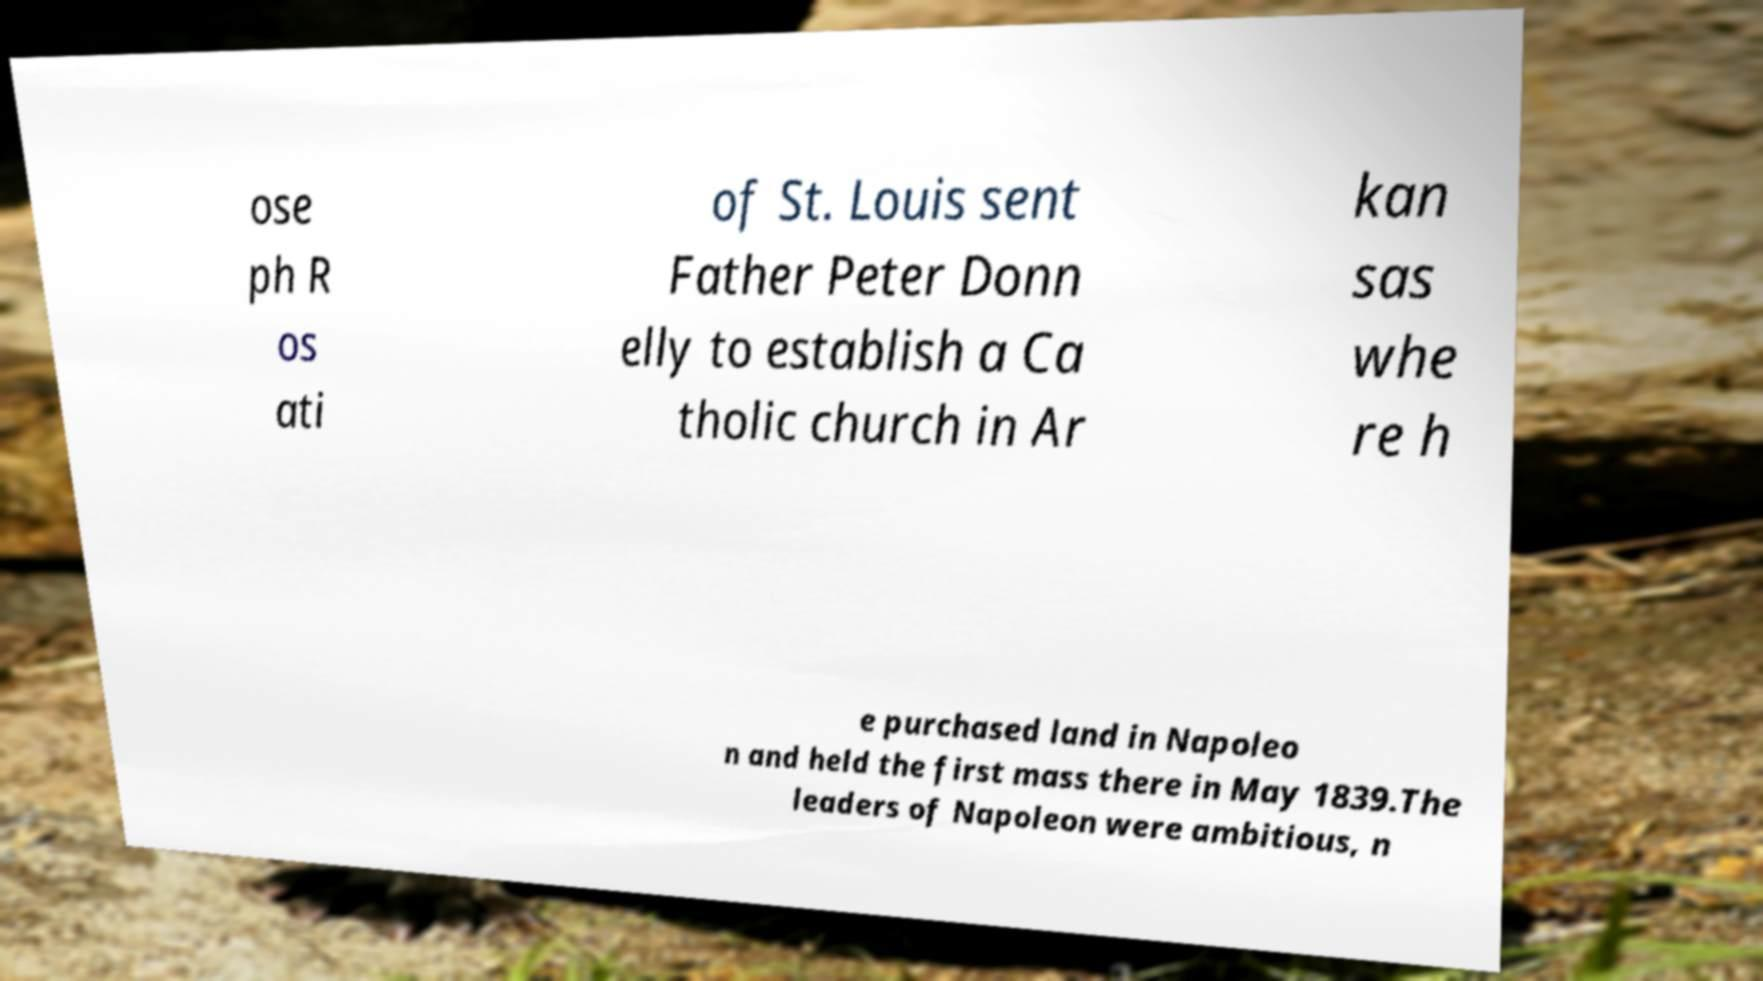Could you assist in decoding the text presented in this image and type it out clearly? ose ph R os ati of St. Louis sent Father Peter Donn elly to establish a Ca tholic church in Ar kan sas whe re h e purchased land in Napoleo n and held the first mass there in May 1839.The leaders of Napoleon were ambitious, n 